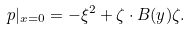Convert formula to latex. <formula><loc_0><loc_0><loc_500><loc_500>p | _ { x = 0 } = - \xi ^ { 2 } + \zeta \cdot B ( y ) \zeta .</formula> 